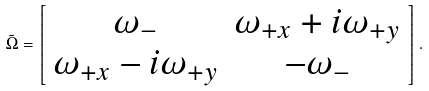<formula> <loc_0><loc_0><loc_500><loc_500>\tilde { \Omega } = \left [ \begin{array} { c c } \omega _ { - } & \omega _ { + x } + i \omega _ { + y } \\ \omega _ { + x } - i \omega _ { + y } & - \omega _ { - } \end{array} \right ] .</formula> 